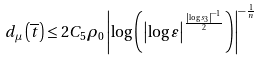<formula> <loc_0><loc_0><loc_500><loc_500>d _ { \mu } \left ( \overline { t } \right ) \leq 2 C _ { 5 } \rho _ { 0 } \left | \log \left ( \left | \log \varepsilon \right | ^ { \frac { \left | \log s _ { 3 } \right | ^ { - 1 } } { 2 } } \right ) \right | ^ { - \frac { 1 } { n } }</formula> 